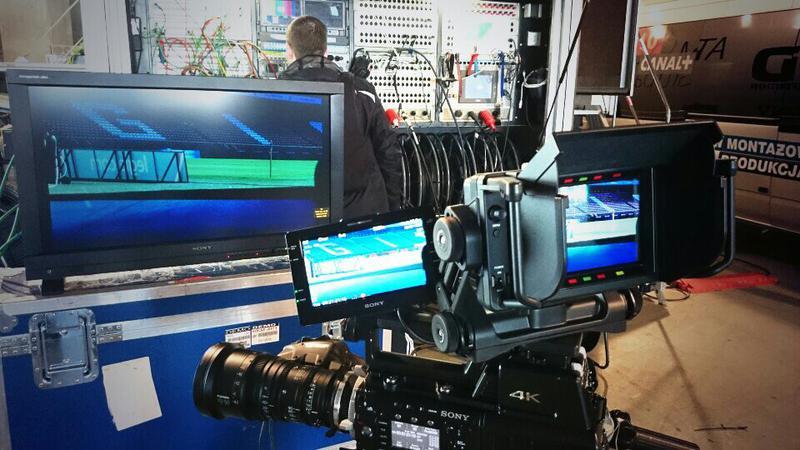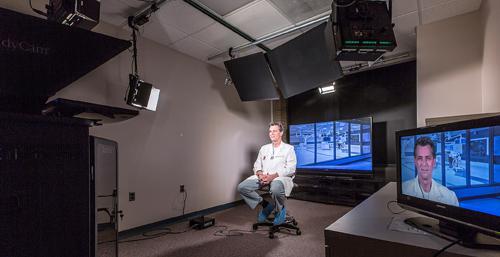The first image is the image on the left, the second image is the image on the right. For the images displayed, is the sentence "The right image shows a seated person in the center, facing cameras." factually correct? Answer yes or no. Yes. 